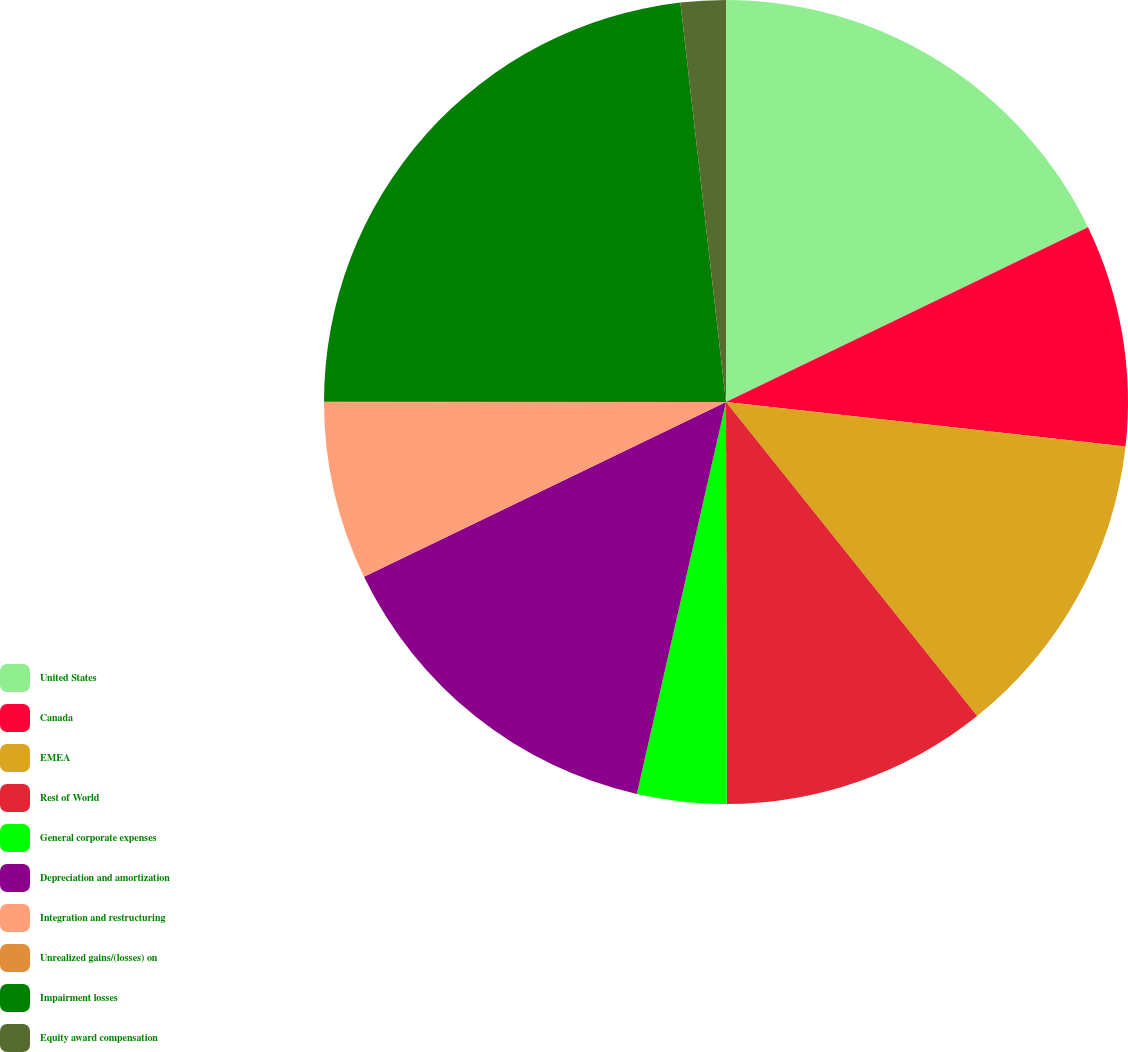Convert chart. <chart><loc_0><loc_0><loc_500><loc_500><pie_chart><fcel>United States<fcel>Canada<fcel>EMEA<fcel>Rest of World<fcel>General corporate expenses<fcel>Depreciation and amortization<fcel>Integration and restructuring<fcel>Unrealized gains/(losses) on<fcel>Impairment losses<fcel>Equity award compensation<nl><fcel>17.84%<fcel>8.93%<fcel>12.49%<fcel>10.71%<fcel>3.59%<fcel>14.28%<fcel>7.15%<fcel>0.02%<fcel>23.18%<fcel>1.81%<nl></chart> 